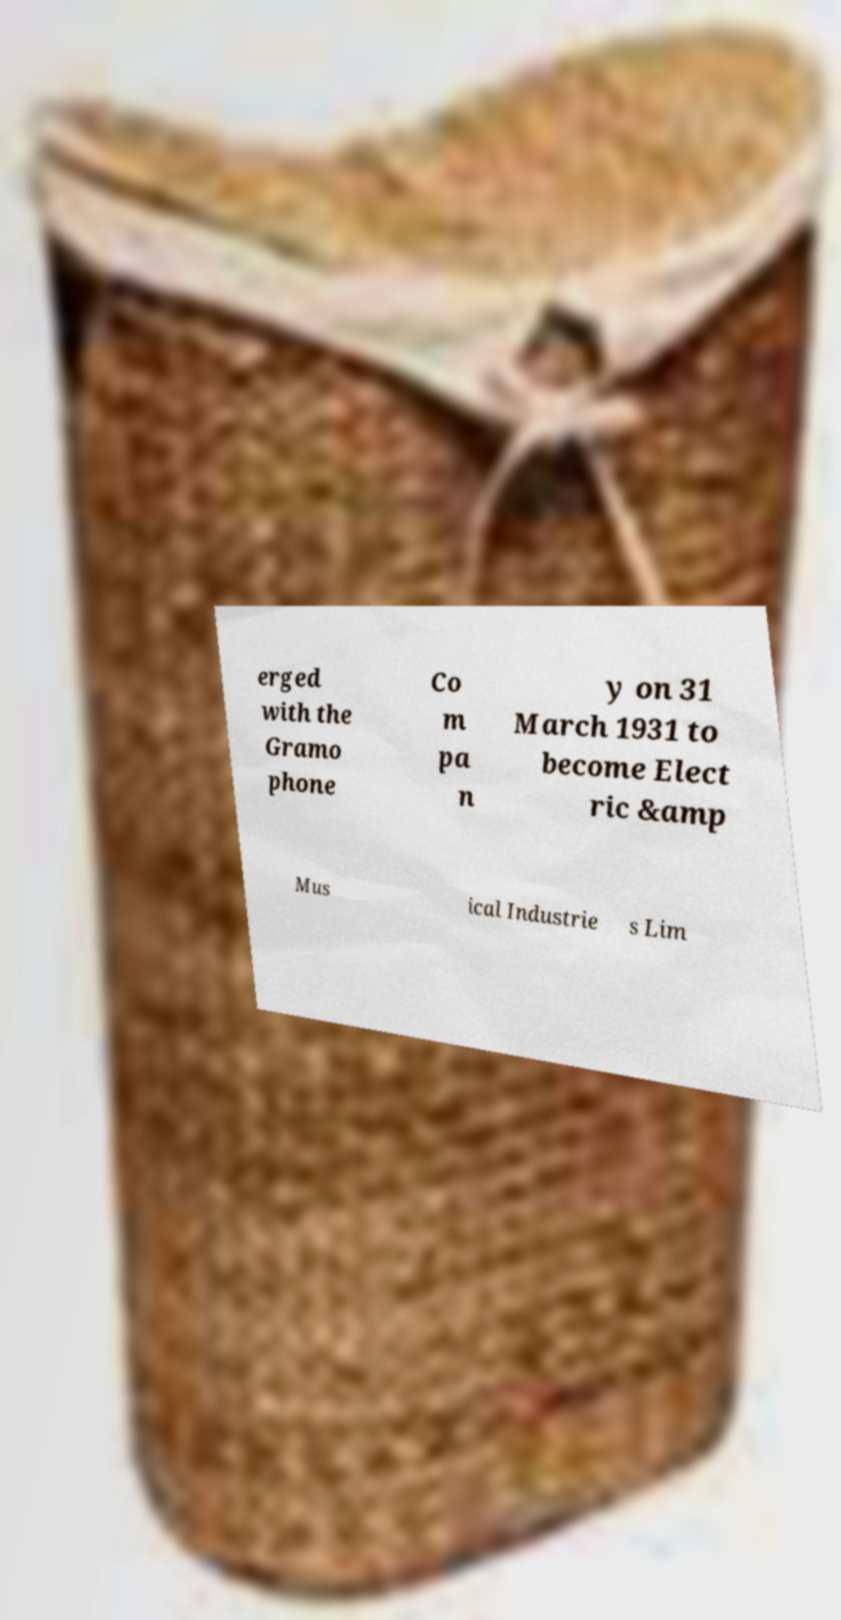Can you accurately transcribe the text from the provided image for me? erged with the Gramo phone Co m pa n y on 31 March 1931 to become Elect ric &amp Mus ical Industrie s Lim 